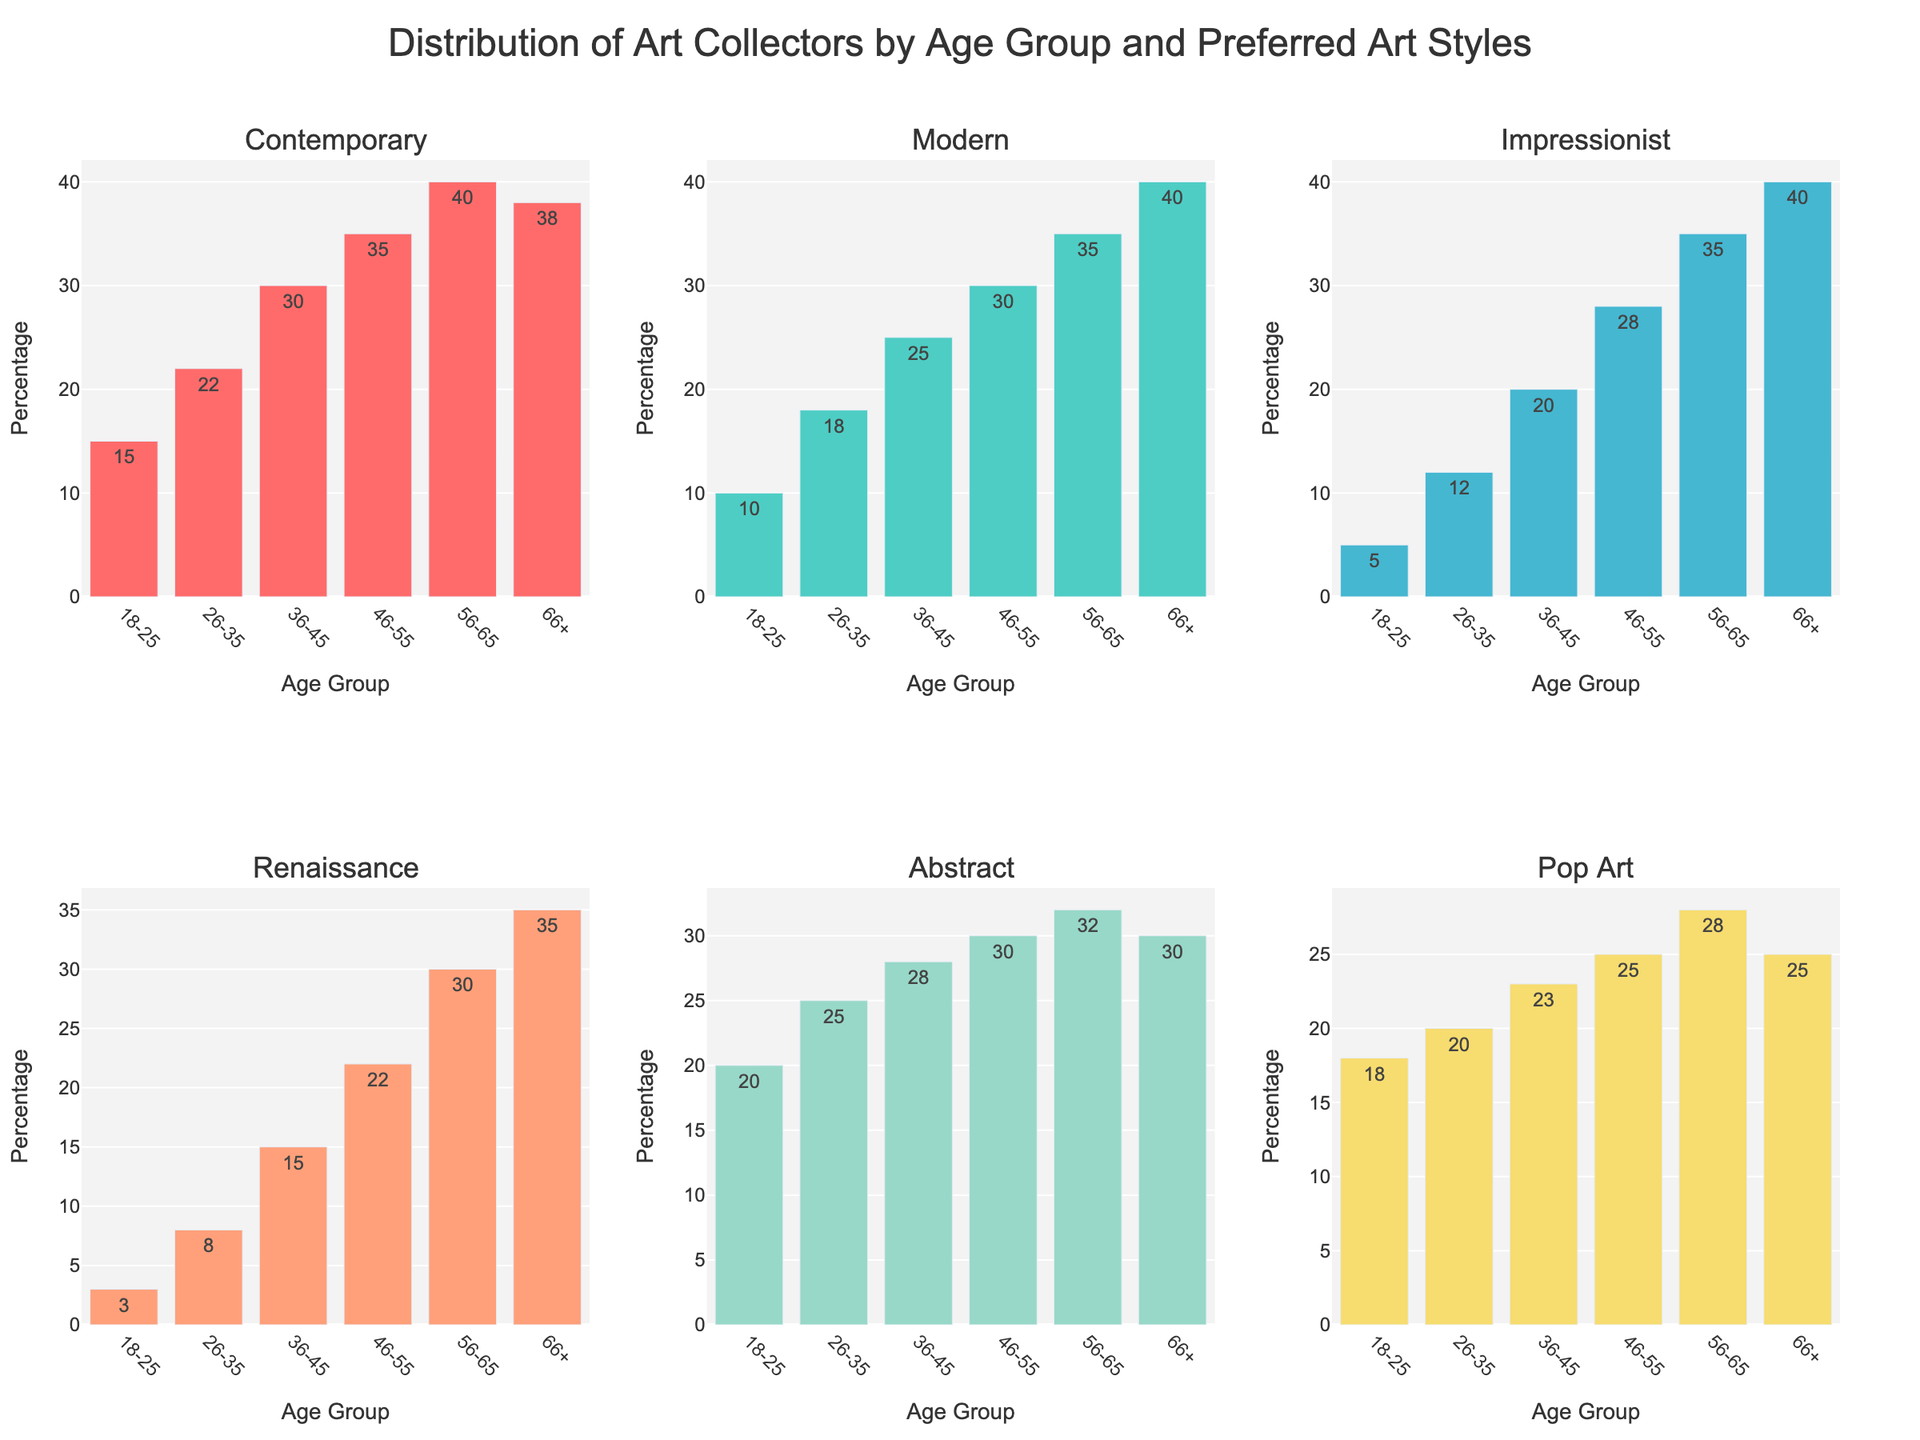What is the most preferred art style by the 36-45 age group? Observe the height of the bars for the 36-45 age group across different art styles. The tallest bar indicates the most preferred art style.
Answer: Abstract Which age group has the highest preference for Renaissance art? Compare the heights of the bars representing Renaissance art across all age groups. The highest bar indicates the age group with the highest preference.
Answer: 66+ How many art styles have higher preferences in the 56-65 age group compared to the 18-25 age group? For each art style, check if the height of the bar for the 56-65 age group is greater than that for the 18-25 age group and count these instances.
Answer: 6 Is the sum of preferences for Pop Art higher in the 26-35 and 36-45 age groups than in the 46-55 and 56-65 groups? Add the percentage values of Pop Art for the 26-35 and 36-45 age groups (20 + 23 = 43) and compare it to the sum for the 46-55 and 56-65 age groups (25 + 28 = 53).
Answer: No Which age group prefers Modern art the least? Observe the heights of the bars for Modern art across all age groups. The shortest bar indicates the age group with the least preference.
Answer: 18-25 How does the preference for Contemporary art change as age increases? Observe the heights of the bars for Contemporary art across increasing age groups. Note whether the heights increase, decrease, or vary irregularly.
Answer: Increases What's the average preference for Impressionist art across all age groups? Add the percentage values for Impressionist art across all age groups (5 + 12 + 20 + 28 + 35 + 40 = 140) and divide by the number of age groups (6).
Answer: 23.33 Is there an age group where the preference for Abstract art is exactly the same as for Renaissance art? Compare the heights of the bars for Abstract art and Renaissance art within each age group to see if they match.
Answer: 46-55 Which two age groups have the nearest preference for Pop Art? Calculate the absolute differences in preference values for Pop Art among all age groups and find the two age groups with the smallest difference.
Answer: 56-65 and 66+ Among all age groups, which art style shows the least variation in preference levels? Calculate the range (difference between highest and lowest values) for each art style preference across all age groups. The smallest range shows the least variation.
Answer: Contemporary 